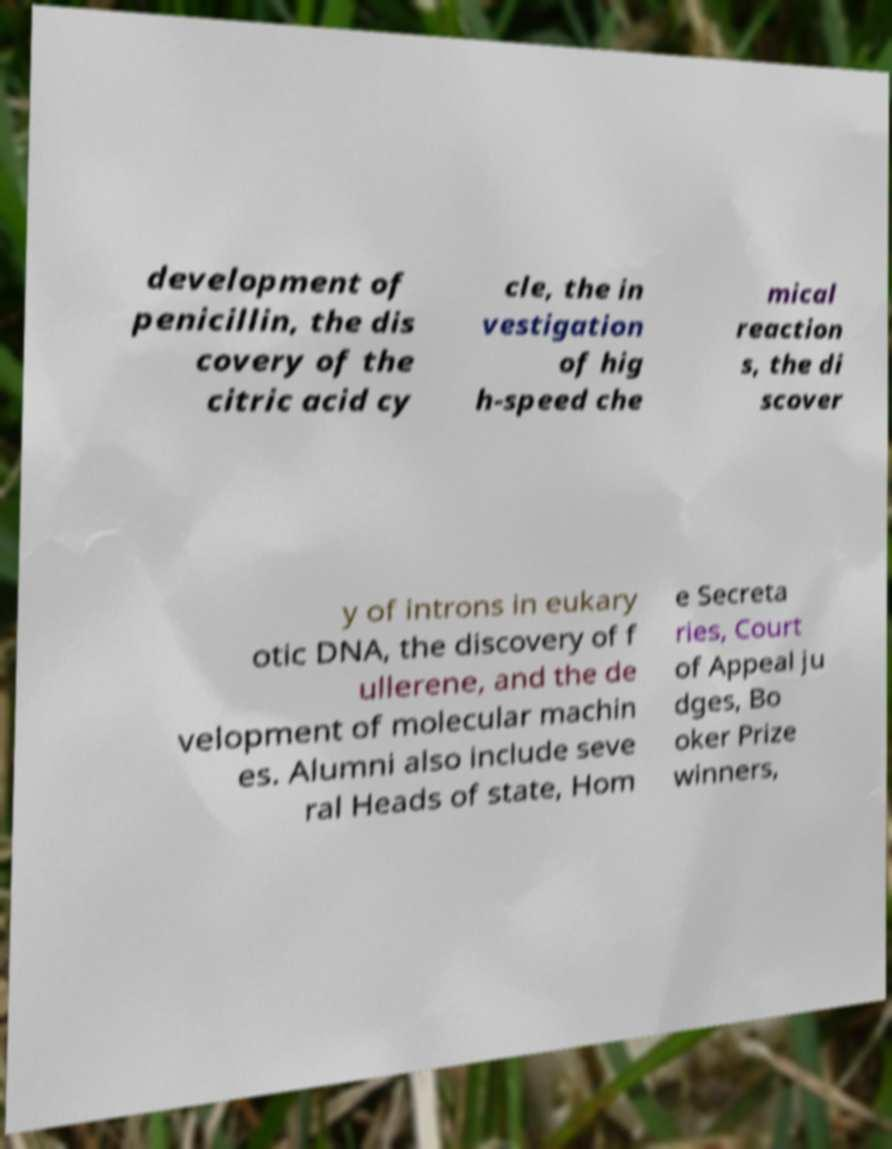Could you extract and type out the text from this image? development of penicillin, the dis covery of the citric acid cy cle, the in vestigation of hig h-speed che mical reaction s, the di scover y of introns in eukary otic DNA, the discovery of f ullerene, and the de velopment of molecular machin es. Alumni also include seve ral Heads of state, Hom e Secreta ries, Court of Appeal ju dges, Bo oker Prize winners, 